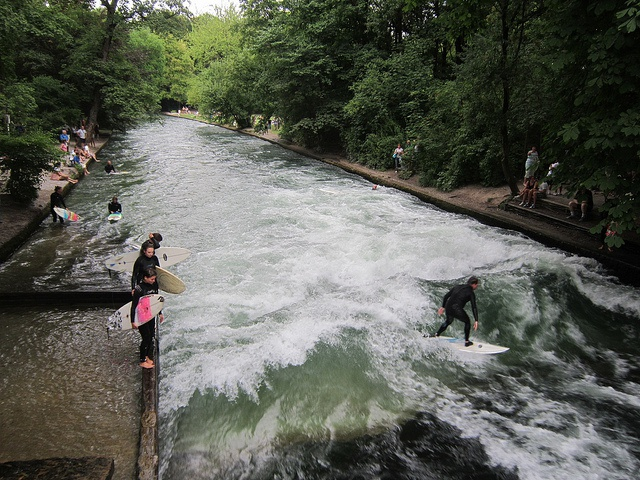Describe the objects in this image and their specific colors. I can see people in darkgreen, black, gray, and darkgray tones, people in darkgreen, black, gray, and brown tones, people in darkgreen, black, gray, brown, and maroon tones, surfboard in darkgreen, darkgray, salmon, and gray tones, and surfboard in darkgreen, darkgray, and lightgray tones in this image. 